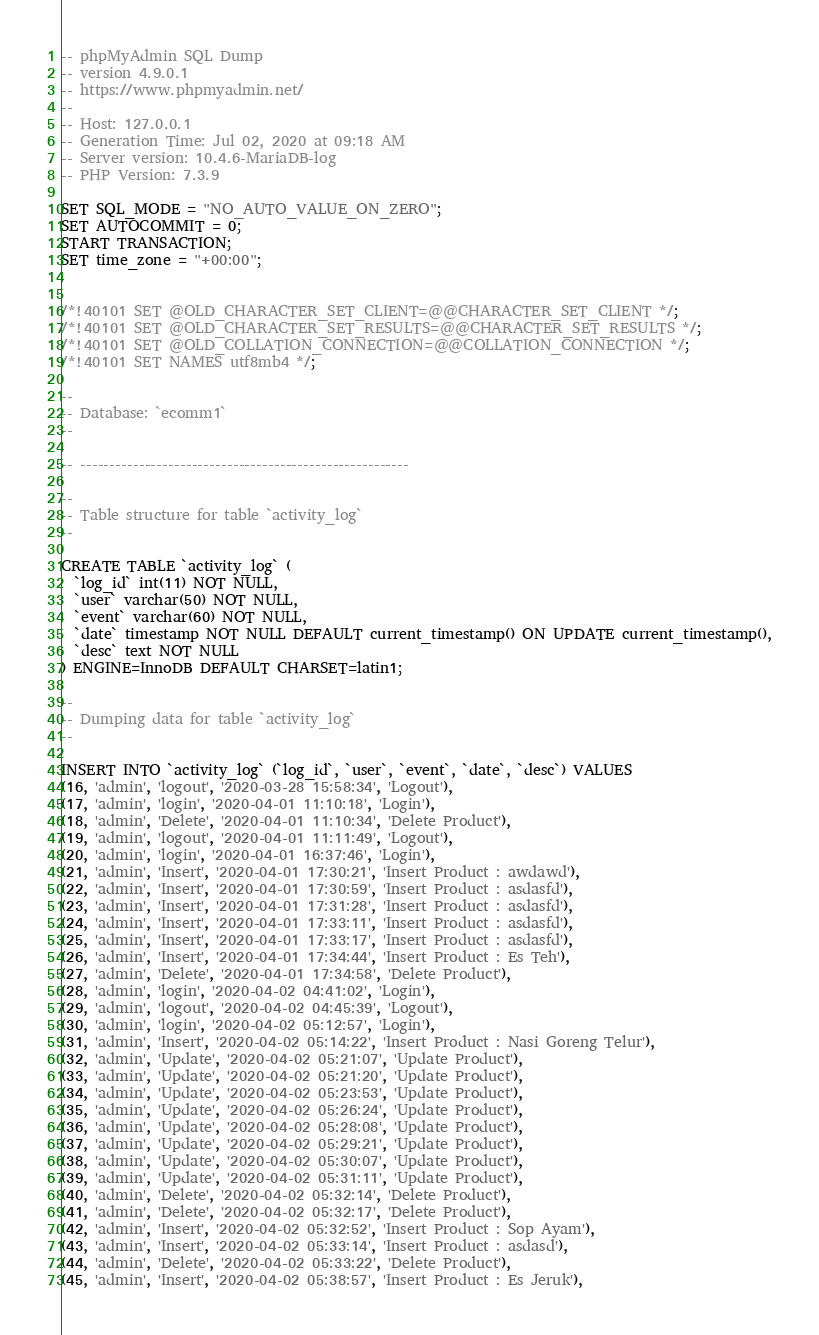<code> <loc_0><loc_0><loc_500><loc_500><_SQL_>-- phpMyAdmin SQL Dump
-- version 4.9.0.1
-- https://www.phpmyadmin.net/
--
-- Host: 127.0.0.1
-- Generation Time: Jul 02, 2020 at 09:18 AM
-- Server version: 10.4.6-MariaDB-log
-- PHP Version: 7.3.9

SET SQL_MODE = "NO_AUTO_VALUE_ON_ZERO";
SET AUTOCOMMIT = 0;
START TRANSACTION;
SET time_zone = "+00:00";


/*!40101 SET @OLD_CHARACTER_SET_CLIENT=@@CHARACTER_SET_CLIENT */;
/*!40101 SET @OLD_CHARACTER_SET_RESULTS=@@CHARACTER_SET_RESULTS */;
/*!40101 SET @OLD_COLLATION_CONNECTION=@@COLLATION_CONNECTION */;
/*!40101 SET NAMES utf8mb4 */;

--
-- Database: `ecomm1`
--

-- --------------------------------------------------------

--
-- Table structure for table `activity_log`
--

CREATE TABLE `activity_log` (
  `log_id` int(11) NOT NULL,
  `user` varchar(50) NOT NULL,
  `event` varchar(60) NOT NULL,
  `date` timestamp NOT NULL DEFAULT current_timestamp() ON UPDATE current_timestamp(),
  `desc` text NOT NULL
) ENGINE=InnoDB DEFAULT CHARSET=latin1;

--
-- Dumping data for table `activity_log`
--

INSERT INTO `activity_log` (`log_id`, `user`, `event`, `date`, `desc`) VALUES
(16, 'admin', 'logout', '2020-03-28 15:58:34', 'Logout'),
(17, 'admin', 'login', '2020-04-01 11:10:18', 'Login'),
(18, 'admin', 'Delete', '2020-04-01 11:10:34', 'Delete Product'),
(19, 'admin', 'logout', '2020-04-01 11:11:49', 'Logout'),
(20, 'admin', 'login', '2020-04-01 16:37:46', 'Login'),
(21, 'admin', 'Insert', '2020-04-01 17:30:21', 'Insert Product : awdawd'),
(22, 'admin', 'Insert', '2020-04-01 17:30:59', 'Insert Product : asdasfd'),
(23, 'admin', 'Insert', '2020-04-01 17:31:28', 'Insert Product : asdasfd'),
(24, 'admin', 'Insert', '2020-04-01 17:33:11', 'Insert Product : asdasfd'),
(25, 'admin', 'Insert', '2020-04-01 17:33:17', 'Insert Product : asdasfd'),
(26, 'admin', 'Insert', '2020-04-01 17:34:44', 'Insert Product : Es Teh'),
(27, 'admin', 'Delete', '2020-04-01 17:34:58', 'Delete Product'),
(28, 'admin', 'login', '2020-04-02 04:41:02', 'Login'),
(29, 'admin', 'logout', '2020-04-02 04:45:39', 'Logout'),
(30, 'admin', 'login', '2020-04-02 05:12:57', 'Login'),
(31, 'admin', 'Insert', '2020-04-02 05:14:22', 'Insert Product : Nasi Goreng Telur'),
(32, 'admin', 'Update', '2020-04-02 05:21:07', 'Update Product'),
(33, 'admin', 'Update', '2020-04-02 05:21:20', 'Update Product'),
(34, 'admin', 'Update', '2020-04-02 05:23:53', 'Update Product'),
(35, 'admin', 'Update', '2020-04-02 05:26:24', 'Update Product'),
(36, 'admin', 'Update', '2020-04-02 05:28:08', 'Update Product'),
(37, 'admin', 'Update', '2020-04-02 05:29:21', 'Update Product'),
(38, 'admin', 'Update', '2020-04-02 05:30:07', 'Update Product'),
(39, 'admin', 'Update', '2020-04-02 05:31:11', 'Update Product'),
(40, 'admin', 'Delete', '2020-04-02 05:32:14', 'Delete Product'),
(41, 'admin', 'Delete', '2020-04-02 05:32:17', 'Delete Product'),
(42, 'admin', 'Insert', '2020-04-02 05:32:52', 'Insert Product : Sop Ayam'),
(43, 'admin', 'Insert', '2020-04-02 05:33:14', 'Insert Product : asdasd'),
(44, 'admin', 'Delete', '2020-04-02 05:33:22', 'Delete Product'),
(45, 'admin', 'Insert', '2020-04-02 05:38:57', 'Insert Product : Es Jeruk'),</code> 